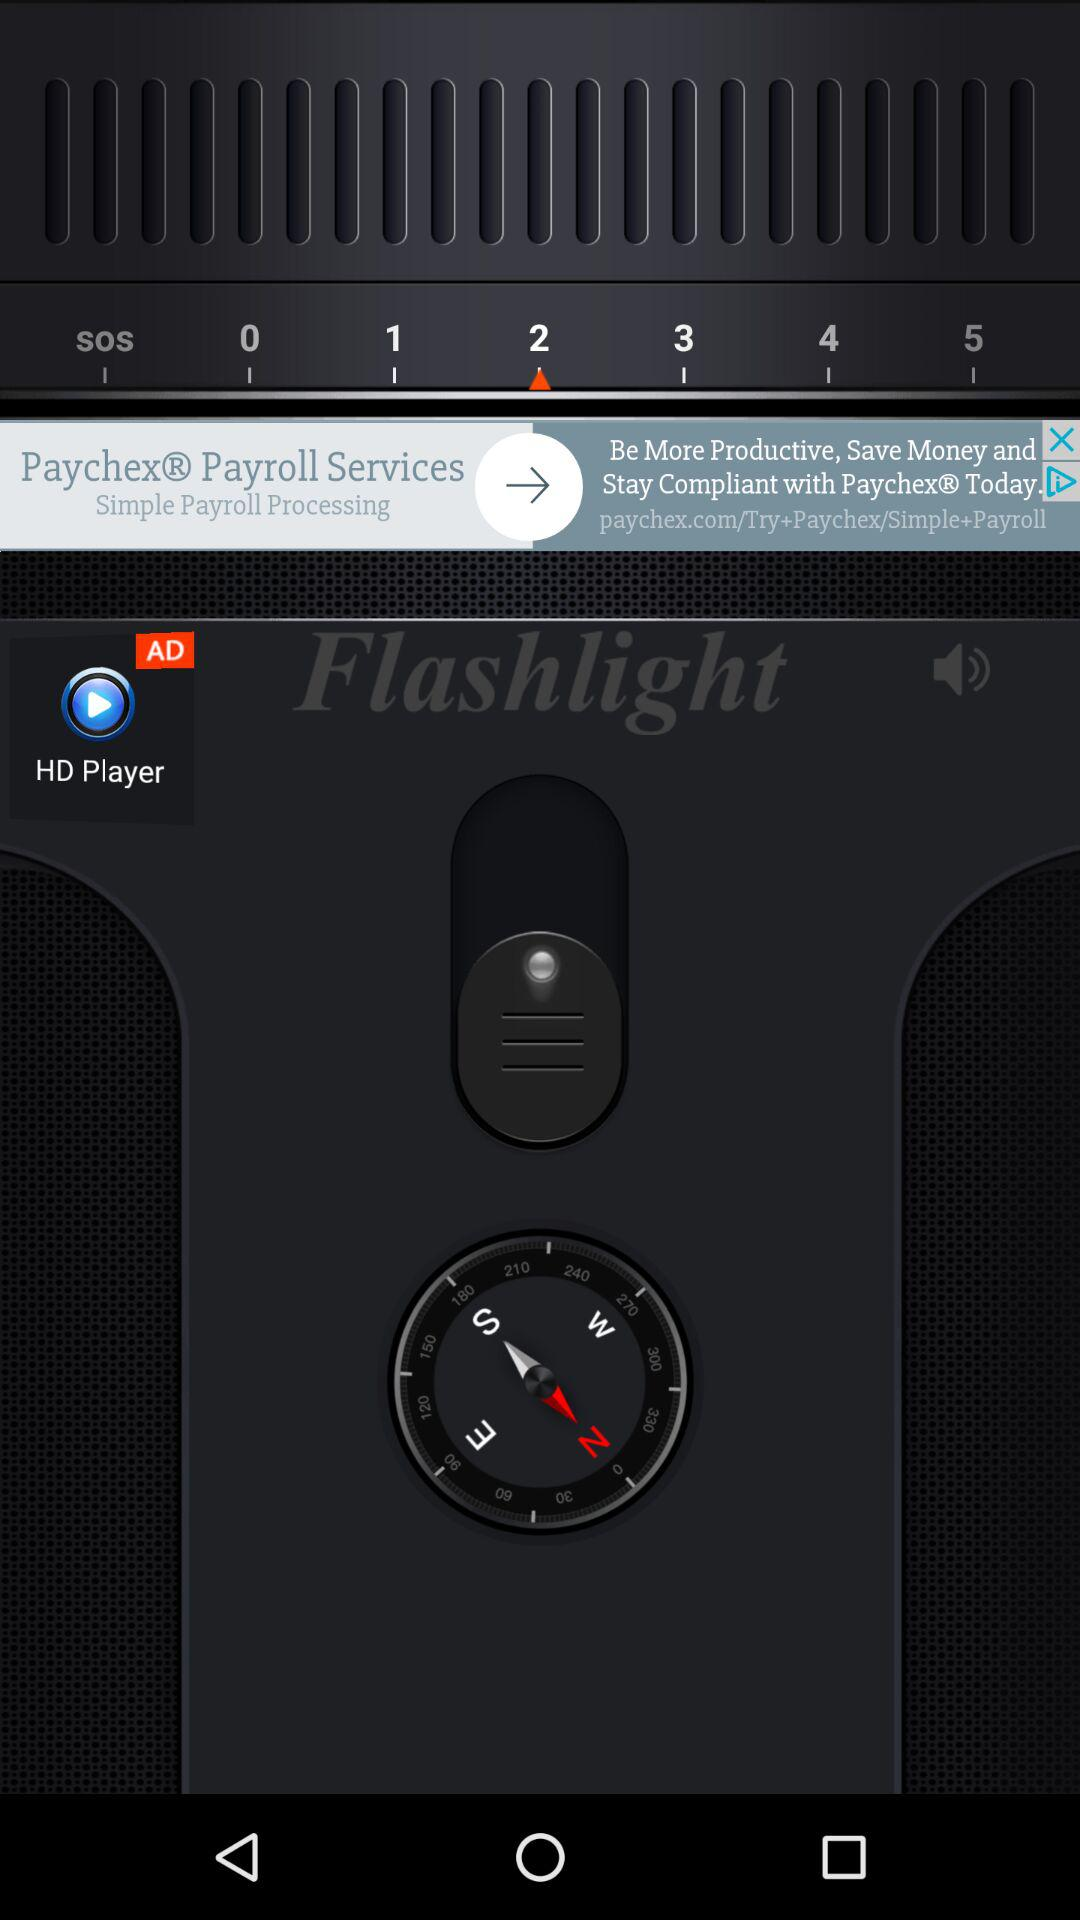How many numbers are displayed on the screen?
Answer the question using a single word or phrase. 6 